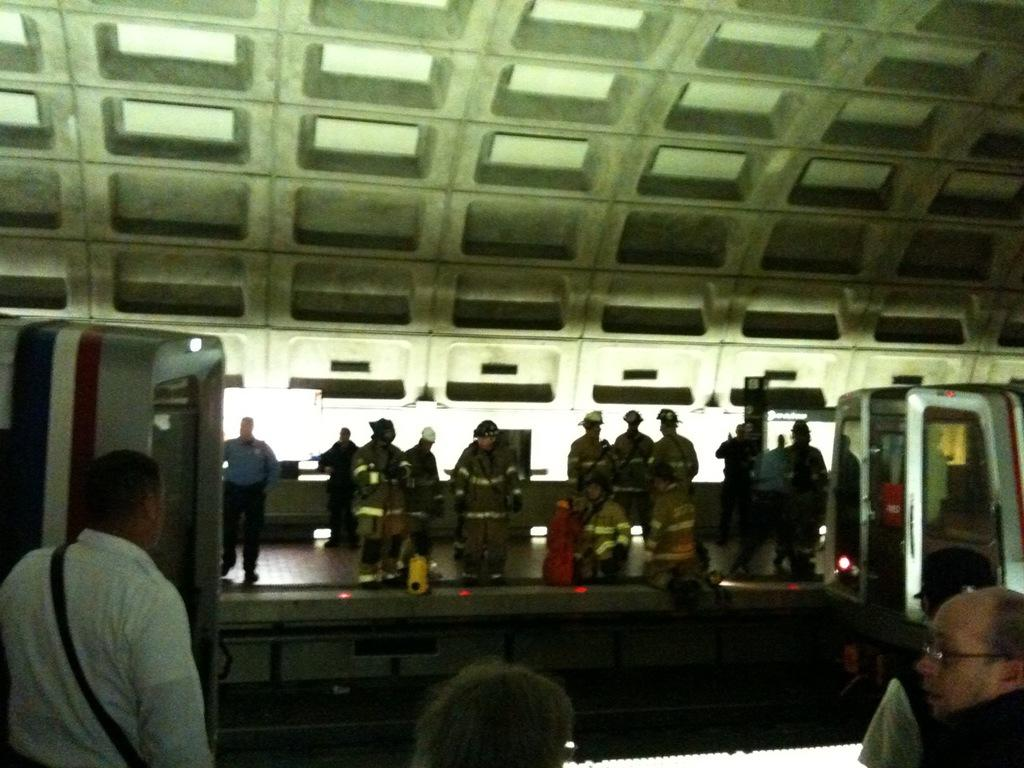What is the main subject of the picture? The main subject of the picture is a train. What can be seen around the train in the image? There are people standing on either side of the train on a platform. How many balls are being juggled by the person standing on the platform? There are no balls or juggling activity present in the image. Is there a skateboard visible on the platform? There is no skateboard visible in the image. 